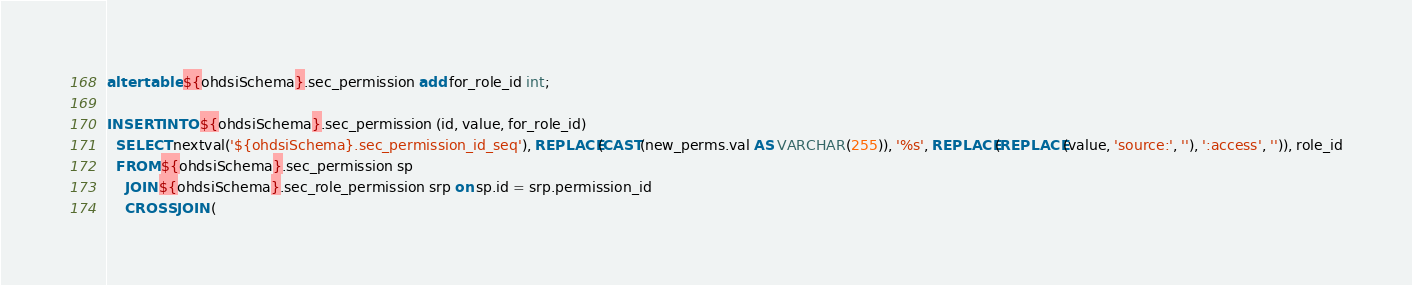Convert code to text. <code><loc_0><loc_0><loc_500><loc_500><_SQL_>alter table ${ohdsiSchema}.sec_permission add for_role_id int;

INSERT INTO ${ohdsiSchema}.sec_permission (id, value, for_role_id)
  SELECT nextval('${ohdsiSchema}.sec_permission_id_seq'), REPLACE(CAST(new_perms.val AS VARCHAR(255)), '%s', REPLACE(REPLACE(value, 'source:', ''), ':access', '')), role_id
  FROM ${ohdsiSchema}.sec_permission sp
    JOIN ${ohdsiSchema}.sec_role_permission srp on sp.id = srp.permission_id
    CROSS JOIN (</code> 